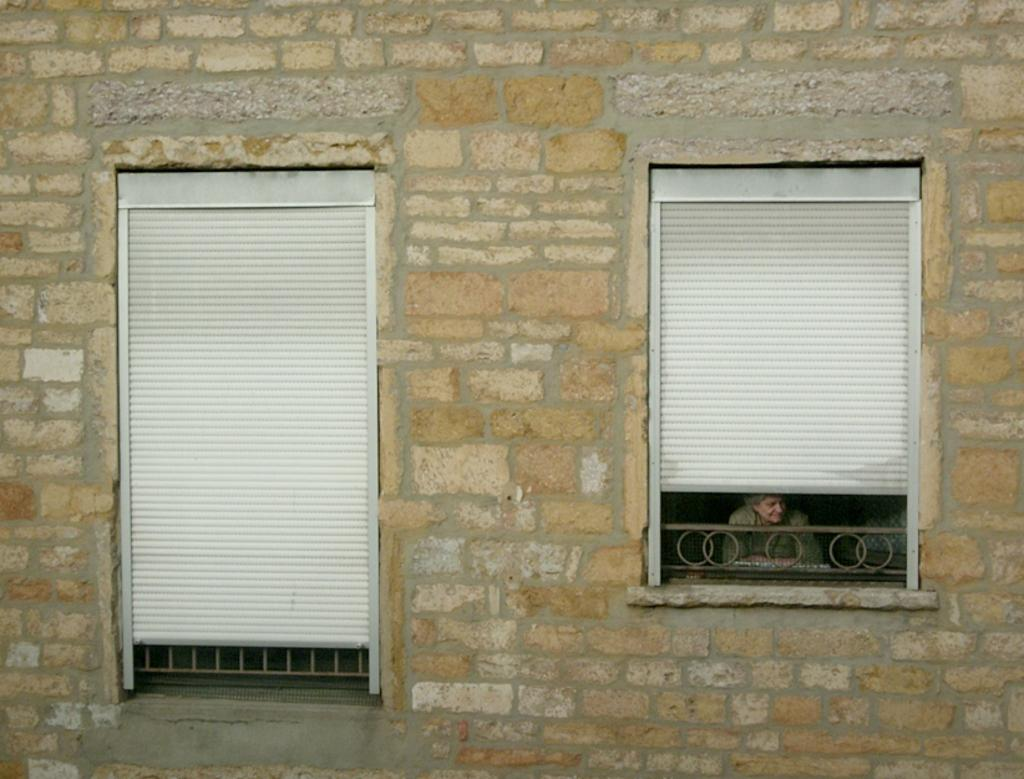How many windows are visible in the image? There are two windows in the image. What is the context of these windows? The windows are part of a wall. Can you describe the person visible behind one of the windows? There is a person visible behind the right window, and they are smiling. What direction is the person looking? The person is looking to the right side. What type of nerve can be seen in the image? There is no nerve present in the image; it features two windows and a person looking to the right side. 